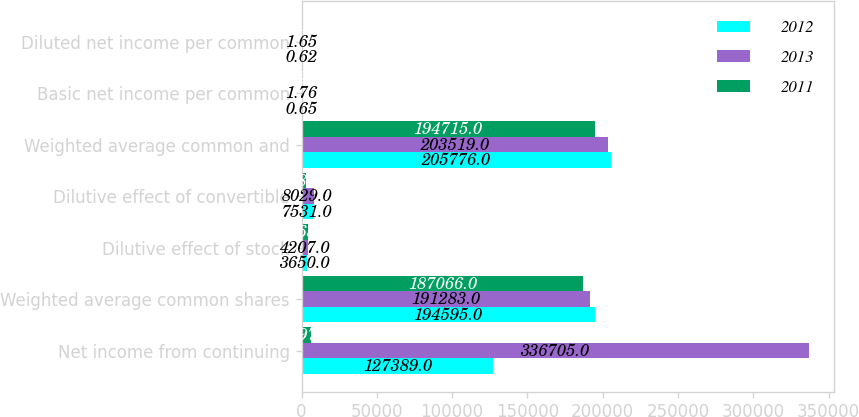<chart> <loc_0><loc_0><loc_500><loc_500><stacked_bar_chart><ecel><fcel>Net income from continuing<fcel>Weighted average common shares<fcel>Dilutive effect of stock<fcel>Dilutive effect of convertible<fcel>Weighted average common and<fcel>Basic net income per common<fcel>Diluted net income per common<nl><fcel>2012<fcel>127389<fcel>194595<fcel>3650<fcel>7531<fcel>205776<fcel>0.65<fcel>0.62<nl><fcel>2013<fcel>336705<fcel>191283<fcel>4207<fcel>8029<fcel>203519<fcel>1.76<fcel>1.65<nl><fcel>2011<fcel>5997<fcel>187066<fcel>4463<fcel>3186<fcel>194715<fcel>2.29<fcel>2.2<nl></chart> 